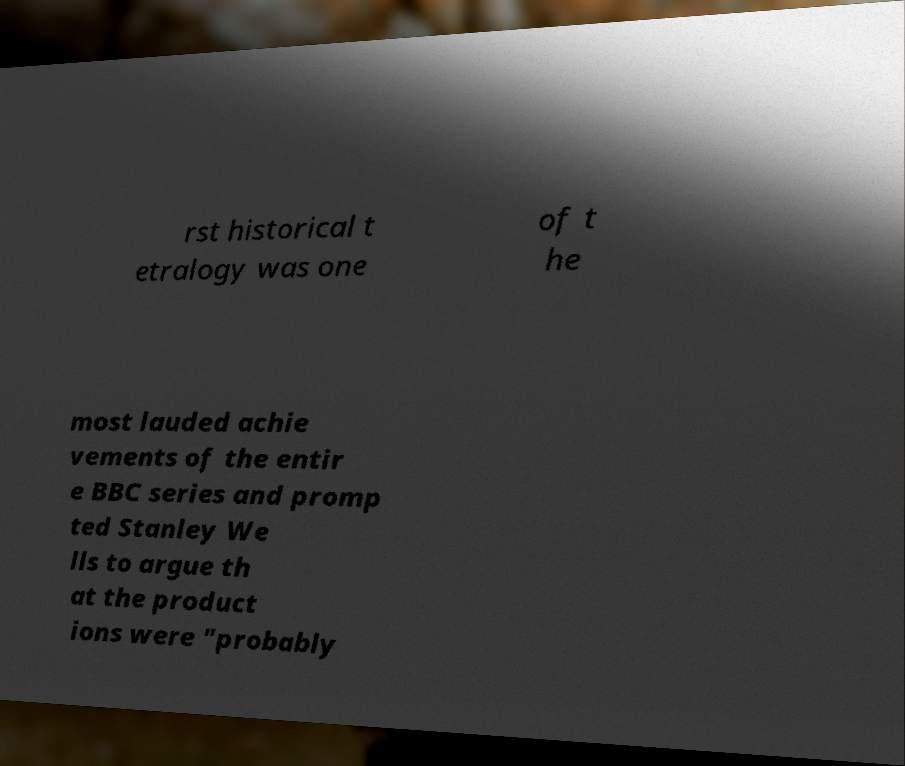What messages or text are displayed in this image? I need them in a readable, typed format. rst historical t etralogy was one of t he most lauded achie vements of the entir e BBC series and promp ted Stanley We lls to argue th at the product ions were "probably 